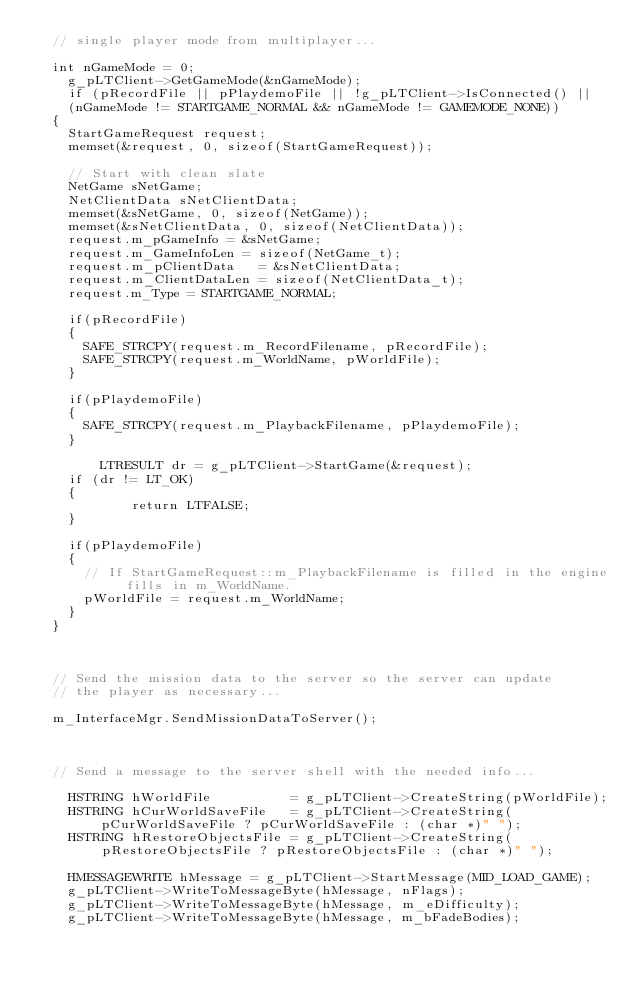<code> <loc_0><loc_0><loc_500><loc_500><_C++_>	// single player mode from multiplayer...

	int nGameMode = 0;
    g_pLTClient->GetGameMode(&nGameMode);
    if (pRecordFile || pPlaydemoFile || !g_pLTClient->IsConnected() ||
		(nGameMode != STARTGAME_NORMAL && nGameMode != GAMEMODE_NONE))
	{
		StartGameRequest request;
		memset(&request, 0, sizeof(StartGameRequest));

		// Start with clean slate
		NetGame sNetGame;
		NetClientData sNetClientData;
		memset(&sNetGame, 0, sizeof(NetGame));
		memset(&sNetClientData, 0, sizeof(NetClientData));
		request.m_pGameInfo = &sNetGame;
		request.m_GameInfoLen = sizeof(NetGame_t);
		request.m_pClientData   = &sNetClientData;
		request.m_ClientDataLen = sizeof(NetClientData_t);
		request.m_Type = STARTGAME_NORMAL;

		if(pRecordFile)
		{
			SAFE_STRCPY(request.m_RecordFilename, pRecordFile);
			SAFE_STRCPY(request.m_WorldName, pWorldFile);
		}

		if(pPlaydemoFile)
		{
			SAFE_STRCPY(request.m_PlaybackFilename, pPlaydemoFile);
		}

        LTRESULT dr = g_pLTClient->StartGame(&request);
		if (dr != LT_OK)
		{
            return LTFALSE;
		}

		if(pPlaydemoFile)
		{
			// If StartGameRequest::m_PlaybackFilename is filled in the engine fills in m_WorldName.
			pWorldFile = request.m_WorldName;
		}
	}



	// Send the mission data to the server so the server can update
	// the player as necessary...

	m_InterfaceMgr.SendMissionDataToServer();



	// Send a message to the server shell with the needed info...

    HSTRING hWorldFile          = g_pLTClient->CreateString(pWorldFile);
    HSTRING hCurWorldSaveFile   = g_pLTClient->CreateString(pCurWorldSaveFile ? pCurWorldSaveFile : (char *)" ");
    HSTRING hRestoreObjectsFile = g_pLTClient->CreateString(pRestoreObjectsFile ? pRestoreObjectsFile : (char *)" ");

    HMESSAGEWRITE hMessage = g_pLTClient->StartMessage(MID_LOAD_GAME);
    g_pLTClient->WriteToMessageByte(hMessage, nFlags);
    g_pLTClient->WriteToMessageByte(hMessage, m_eDifficulty);
    g_pLTClient->WriteToMessageByte(hMessage, m_bFadeBodies);</code> 